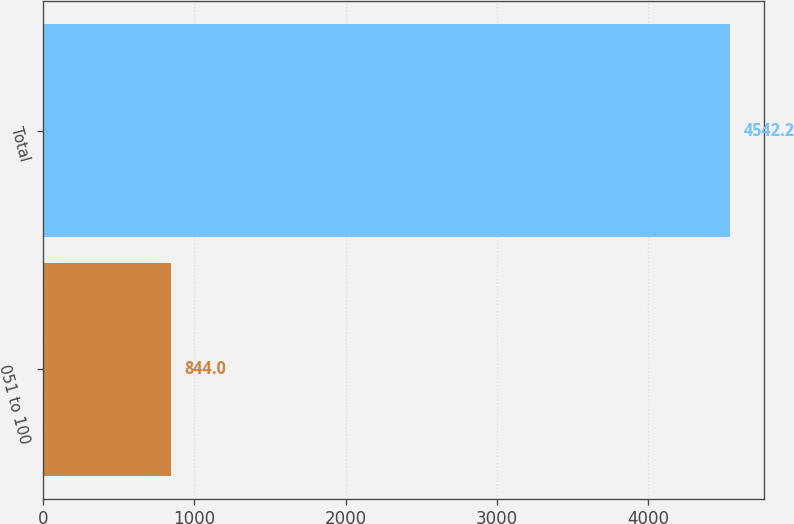Convert chart to OTSL. <chart><loc_0><loc_0><loc_500><loc_500><bar_chart><fcel>051 to 100<fcel>Total<nl><fcel>844<fcel>4542.2<nl></chart> 